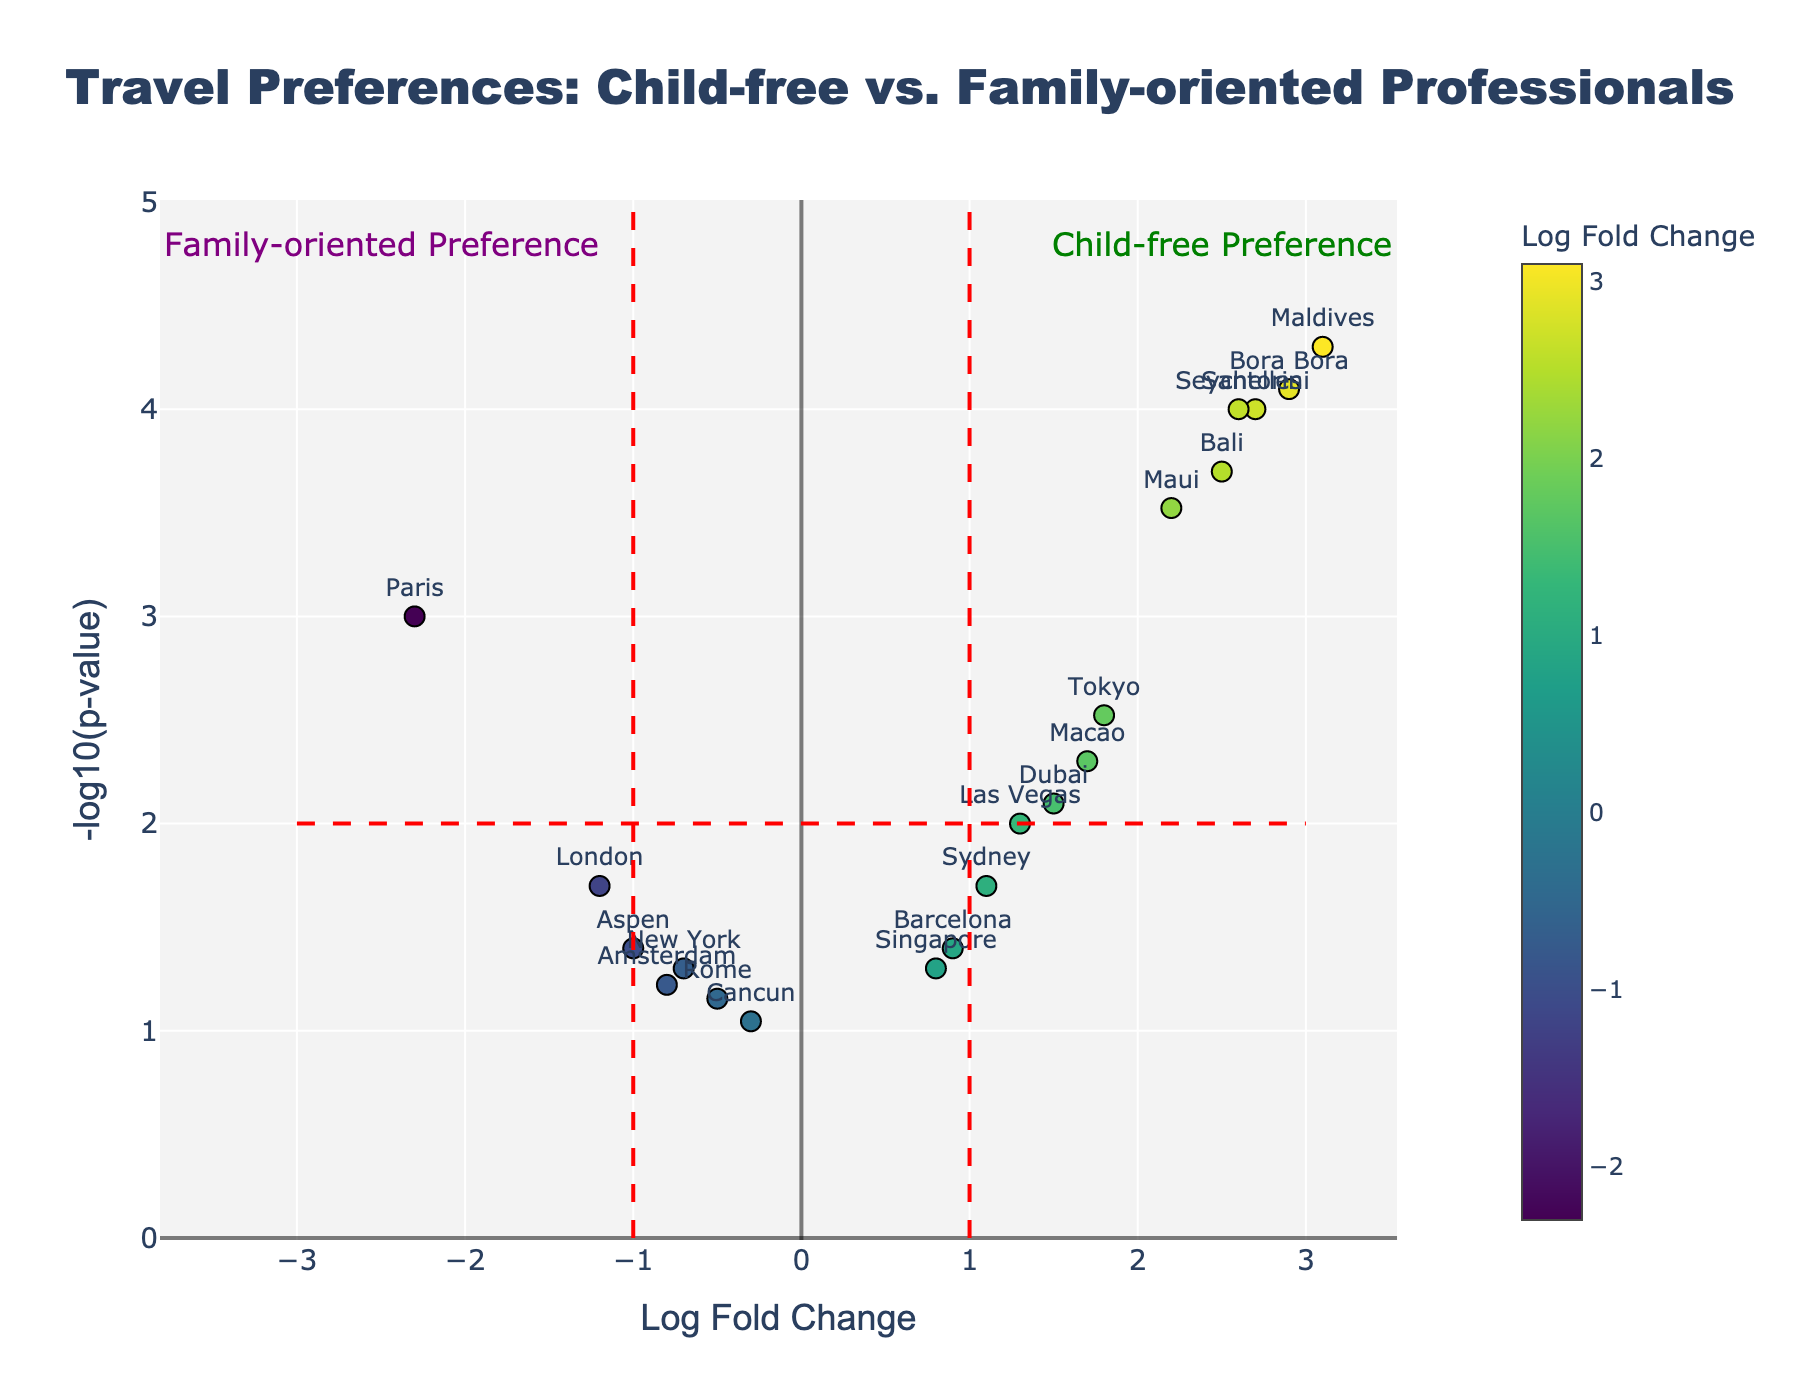Where is the data point for Paris located in terms of Log Fold Change and -log10(p-value)? Paris has a Log Fold Change of -2.3 and -log10(p-value) calculated from the p-value of 0.001. This places Paris at the coordinates (-2.3, log10(1/0.001) = 3) on the plot.
Answer: (-2.3, 3) Which destination shows the highest child-free preference? We need to identify the data point with the highest positive Log Fold Change and significant -log10(p-value). Maldives has the highest Log Fold Change of 3.1 and a highly significant -log10(p-value) of approximately 4.3 (since p-value is 0.00005).
Answer: Maldives How many destinations indicate a family-oriented preference? Family-oriented preferences are shown by negative Log Fold Change values. The destinations with negative Log Fold Changes (Paris, New York, London, Rome, Cancun, Amsterdam, and Aspen) sum up to 7 data points.
Answer: 7 Which destination has the highest significance for child-free professionals? The highest child-free significance will have a low p-value and high -log10(p-value), alongside a positive Log Fold Change. Maldives, with the highest Log Fold Change of 3.1 and very small p-value of 0.00005, has approximately -log10(0.00005) = 4.3.
Answer: Maldives Is Rome considered a significant preference for family-oriented professionals? Significance is denoted by -log10(p-value > 2). Rome has a p-value of 0.07, which translates into -log10(0.07) ≈ 1.2, indicating that Rome does not meet the significance threshold (-log10(p-value) < 2).
Answer: No What can you infer about destinations with a Log Fold Change close to zero? Destinations near zero Log Fold Change (like New York, Rome, Cancun, and Amsterdam) imply no strong preference towards either child-free or family-oriented professionals. Each has -log10(p-value) below the significance threshold of 2.
Answer: Neutral preference How many destinations have a Log Fold Change greater than 2? We need to count data points with Log Fold Change > 2. The destinations are Bali (2.5), Maldives (3.1), Santorini (2.7), Bora Bora (2.9), Maui (2.2), and Seychelles (2.6).
Answer: 6 